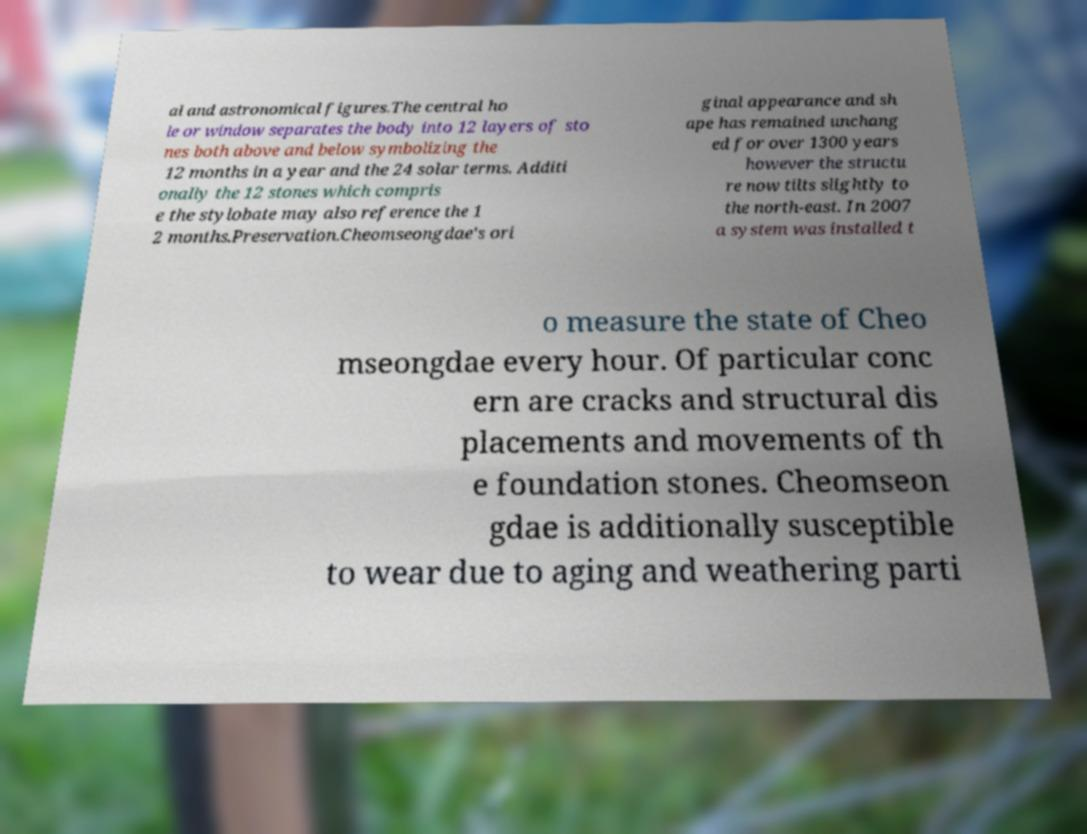Can you accurately transcribe the text from the provided image for me? al and astronomical figures.The central ho le or window separates the body into 12 layers of sto nes both above and below symbolizing the 12 months in a year and the 24 solar terms. Additi onally the 12 stones which compris e the stylobate may also reference the 1 2 months.Preservation.Cheomseongdae's ori ginal appearance and sh ape has remained unchang ed for over 1300 years however the structu re now tilts slightly to the north-east. In 2007 a system was installed t o measure the state of Cheo mseongdae every hour. Of particular conc ern are cracks and structural dis placements and movements of th e foundation stones. Cheomseon gdae is additionally susceptible to wear due to aging and weathering parti 